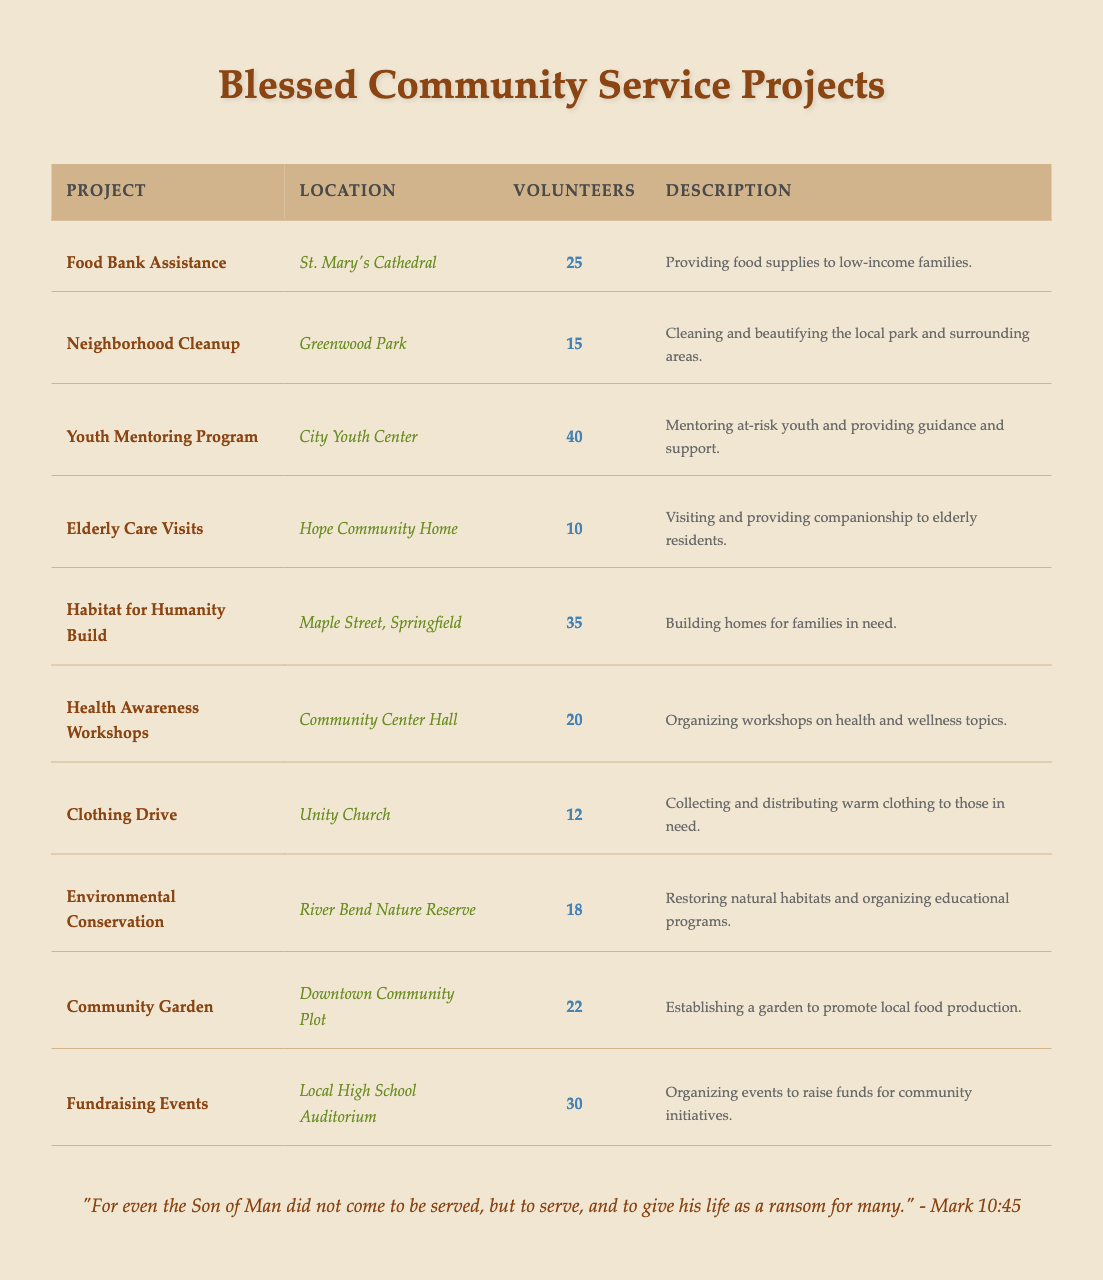How many volunteers are involved in the "Youth Mentoring Program"? The table lists the number of volunteers for each project. The "Youth Mentoring Program" has 40 volunteers mentioned in the corresponding row.
Answer: 40 What is the location of the "Clothing Drive"? Each project in the table has a specified location. Looking at the row for "Clothing Drive," the location is listed as "Unity Church."
Answer: Unity Church Which project has the least number of volunteers? To find this, we compare the number of volunteers across all projects. "Elderly Care Visits" has the least number of volunteers at 10.
Answer: Elderly Care Visits What is the total number of volunteers across all projects? We sum the volunteers from each project: 25 + 15 + 40 + 10 + 35 + 20 + 12 + 18 + 22 + 30 =  227.
Answer: 227 Which project is located at "Maple Street, Springfield"? The table directly indicates the projects and their locations. The project located at "Maple Street, Springfield" is "Habitat for Humanity Build."
Answer: Habitat for Humanity Build How many more volunteers participated in "Health Awareness Workshops" than "Neighborhood Cleanup"? From the table, "Health Awareness Workshops" has 20 volunteers and "Neighborhood Cleanup" has 15. Subtracting these gives 20 - 15 = 5 more volunteers.
Answer: 5 Is the "Environmental Conservation" project supported by more volunteers than the "Clothing Drive"? The "Environmental Conservation" project has 18 volunteers, and the "Clothing Drive" has 12. Since 18 > 12, the statement is true.
Answer: Yes Which project involves building homes and how many volunteers does it have? The project that involves building homes is "Habitat for Humanity Build" and it has 35 volunteers.
Answer: Habitat for Humanity Build, 35 What percentage of the total volunteers are involved in "Fundraising Events"? First, find the total number of volunteers, which is 227 (as calculated earlier). The "Fundraising Events" has 30 volunteers. The percentage is (30/227) * 100 ≈ 13.2%.
Answer: 13.2% If we combine the number of volunteers from "Food Bank Assistance" and "Community Garden," how many volunteers would that be? "Food Bank Assistance" has 25 volunteers and "Community Garden" has 22 volunteers. Adding these two gives 25 + 22 = 47 volunteers combined.
Answer: 47 